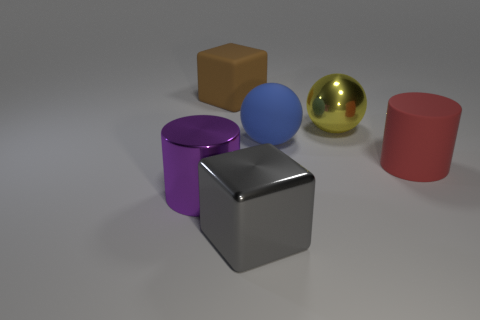Is there any other thing that has the same size as the yellow metal sphere?
Your answer should be very brief. Yes. There is a object that is both in front of the large yellow object and behind the red cylinder; what shape is it?
Provide a succinct answer. Sphere. There is a big rubber sphere; what number of large metallic cubes are in front of it?
Ensure brevity in your answer.  1. Is the number of cylinders less than the number of red matte things?
Your answer should be very brief. No. How big is the thing that is on the right side of the large blue object and in front of the yellow object?
Keep it short and to the point. Large. What is the size of the metallic object on the left side of the large block behind the big cylinder on the left side of the brown cube?
Provide a short and direct response. Large. What size is the metal block?
Give a very brief answer. Large. Is there anything else that has the same material as the blue sphere?
Give a very brief answer. Yes. There is a large cylinder left of the cube that is in front of the matte ball; is there a big yellow ball in front of it?
Give a very brief answer. No. How many small things are red rubber things or blue rubber objects?
Offer a very short reply. 0. 